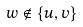<formula> <loc_0><loc_0><loc_500><loc_500>w \notin \{ u , v \}</formula> 